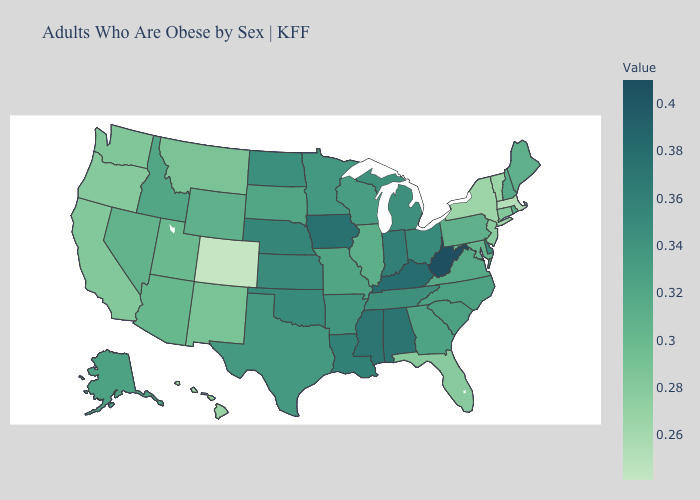Does the map have missing data?
Quick response, please. No. Among the states that border Iowa , does Illinois have the lowest value?
Give a very brief answer. Yes. Among the states that border Alabama , does Florida have the lowest value?
Be succinct. Yes. Among the states that border Tennessee , which have the highest value?
Be succinct. Kentucky. Which states have the lowest value in the USA?
Short answer required. Colorado. 